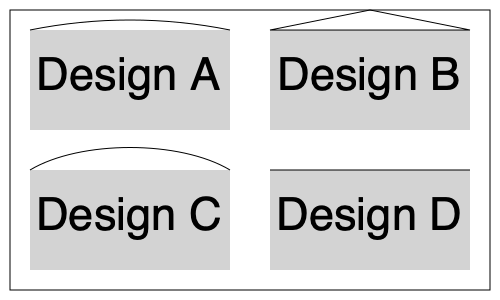Based on the cross-sectional diagrams of four architectural designs for quiet spaces shown above, which design would likely provide the best acoustic isolation from external noise, and why? To determine the best acoustic isolation, we need to consider the principles of sound reflection and absorption:

1. Design A: Features a curved ceiling, which can help diffuse sound waves but may not be optimal for isolation.

2. Design B: Has an angled ceiling, which can reflect sound waves back into the room, potentially creating echoes.

3. Design C: Incorporates a concave ceiling, which might focus sound waves to specific points in the room, possibly creating acoustic hotspots.

4. Design D: Presents a flat ceiling, which is the simplest design but doesn't offer any special acoustic properties.

The key factors for acoustic isolation are:
a) Minimizing sound transmission from outside
b) Reducing sound reflections within the space

Design C, with its concave ceiling, offers the best potential for acoustic isolation because:
1. The curved shape can help diffuse incoming sound waves, reducing their intensity.
2. It provides more volume in the upper part of the room, which can act as a buffer zone for sound.
3. The concave shape can be advantageous for sound absorption when treated with appropriate materials.
4. It avoids parallel surfaces, which can create standing waves and flutter echoes.

To maximize the acoustic isolation, the concave surface should be treated with sound-absorbing materials. The combination of shape and proper treatment would provide superior noise reduction compared to the other designs.
Answer: Design C 